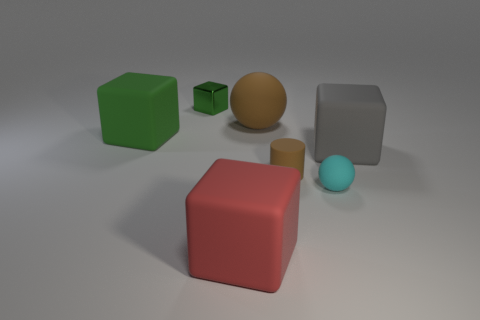Subtract all cyan balls. How many balls are left? 1 Subtract all large blocks. How many blocks are left? 1 Add 1 shiny cubes. How many objects exist? 8 Subtract all large red rubber blocks. Subtract all rubber objects. How many objects are left? 0 Add 4 small matte spheres. How many small matte spheres are left? 5 Add 3 metal blocks. How many metal blocks exist? 4 Subtract 1 brown balls. How many objects are left? 6 Subtract all cylinders. How many objects are left? 6 Subtract 1 cylinders. How many cylinders are left? 0 Subtract all cyan cylinders. Subtract all red blocks. How many cylinders are left? 1 